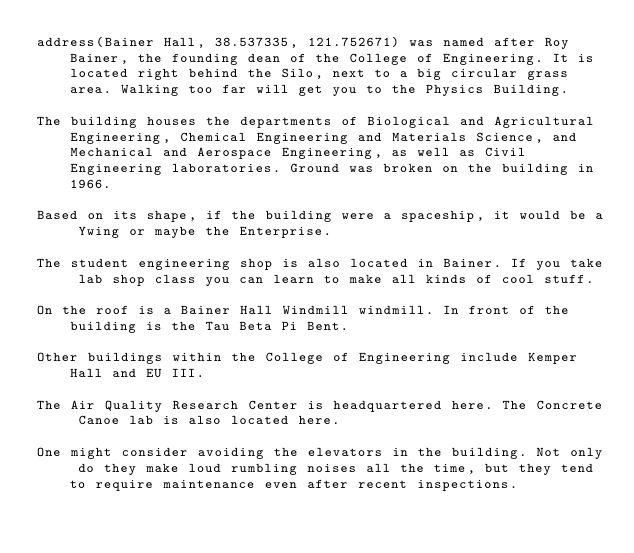<code> <loc_0><loc_0><loc_500><loc_500><_FORTRAN_>address(Bainer Hall, 38.537335, 121.752671) was named after Roy Bainer, the founding dean of the College of Engineering. It is located right behind the Silo, next to a big circular grass area. Walking too far will get you to the Physics Building.

The building houses the departments of Biological and Agricultural Engineering, Chemical Engineering and Materials Science, and Mechanical and Aerospace Engineering, as well as Civil Engineering laboratories. Ground was broken on the building in 1966.

Based on its shape, if the building were a spaceship, it would be a Ywing or maybe the Enterprise.

The student engineering shop is also located in Bainer. If you take lab shop class you can learn to make all kinds of cool stuff.

On the roof is a Bainer Hall Windmill windmill. In front of the building is the Tau Beta Pi Bent.

Other buildings within the College of Engineering include Kemper Hall and EU III.

The Air Quality Research Center is headquartered here. The Concrete Canoe lab is also located here.

One might consider avoiding the elevators in the building. Not only do they make loud rumbling noises all the time, but they tend to require maintenance even after recent inspections.
</code> 